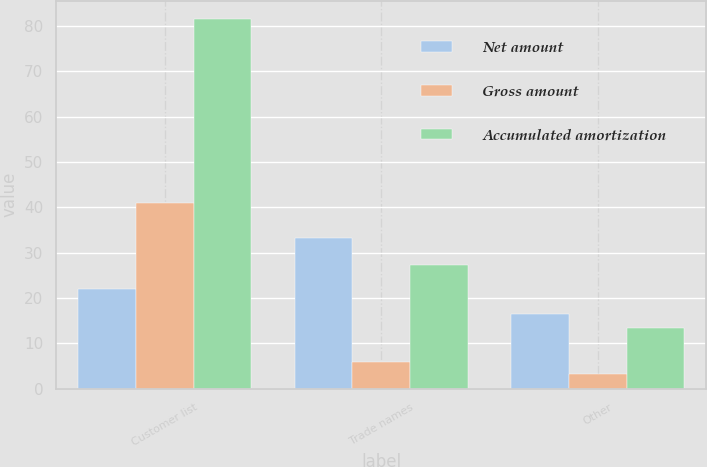Convert chart to OTSL. <chart><loc_0><loc_0><loc_500><loc_500><stacked_bar_chart><ecel><fcel>Customer list<fcel>Trade names<fcel>Other<nl><fcel>Net amount<fcel>21.9<fcel>33.2<fcel>16.5<nl><fcel>Gross amount<fcel>41<fcel>5.9<fcel>3.2<nl><fcel>Accumulated amortization<fcel>81.5<fcel>27.3<fcel>13.3<nl></chart> 